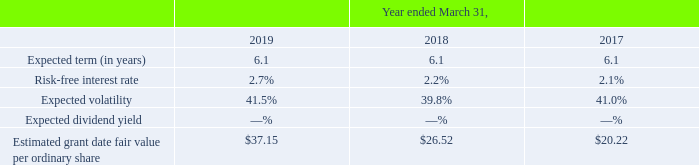Share Options
The Company estimates the fair value of employee share options on the date of grant using the Black-Scholes option-pricing model, which requires the use of highly subjective estimates and assumptions. The Company estimates the expected term of share options for service-based awards utilizing the “Simplified Method,” as it does not have sufficient historical share option exercise information on which to base its estimate. The Simplified Method is based on the average of the vesting tranches and the contractual life of each grant.
The risk-free interest rate is based on a treasury instrument whose term is consistent with the expected life of the share option. Since there was no public market for the Company’s ordinary shares prior to the IPO and as its shares have been publicly traded for a limited time, the Company determined the expected volatility for options granted based on an analysis of reported data for a peer group of companies that issue options with substantially similar terms.
The expected volatility of options granted has been determined using an average of the historical volatility measures of this peer group of companies. The Company uses an expected dividend rate of zero as it currently has no history or expectation of paying dividends on its ordinary shares. The fair value of the Company’s ordinary shares at the time of each share option grant is based on the closing market value of its ordinary shares on the grant date.
The fair value of each share option grant was estimated using the Black-Scholes option-pricing model that used the following weighted-average assumptions:
The weighted-average per share fair value of share options granted to employees during the years ended March 31, 2019, 2018 and 2017 was $16.48, $11.12 and $8.65 per share, respectively.
Which model is used to estimate the fair value of employee share option? Black-scholes option-pricing model. What is the risk free rate based on? Treasury instrument whose term is consistent with the expected life of the share option. What was the Expected term (in years) in 2019, 2018 and 2017 respectively? 6.1, 6.1, 6.1. What was the change in the Risk-free interest rate from 2018 to 2019?
Answer scale should be: percent. 2.7 - 2.2
Answer: 0.5. What was the average Expected volatility between 2017-2019?
Answer scale should be: percent. (41.5 + 39.8 + 41.0) / 3
Answer: 40.77. In which year was Estimated grant date fair value per ordinary share less than 30? Locate and analyze estimated grant date fair value per ordinary share in row 7
answer: 2018, 2017. 